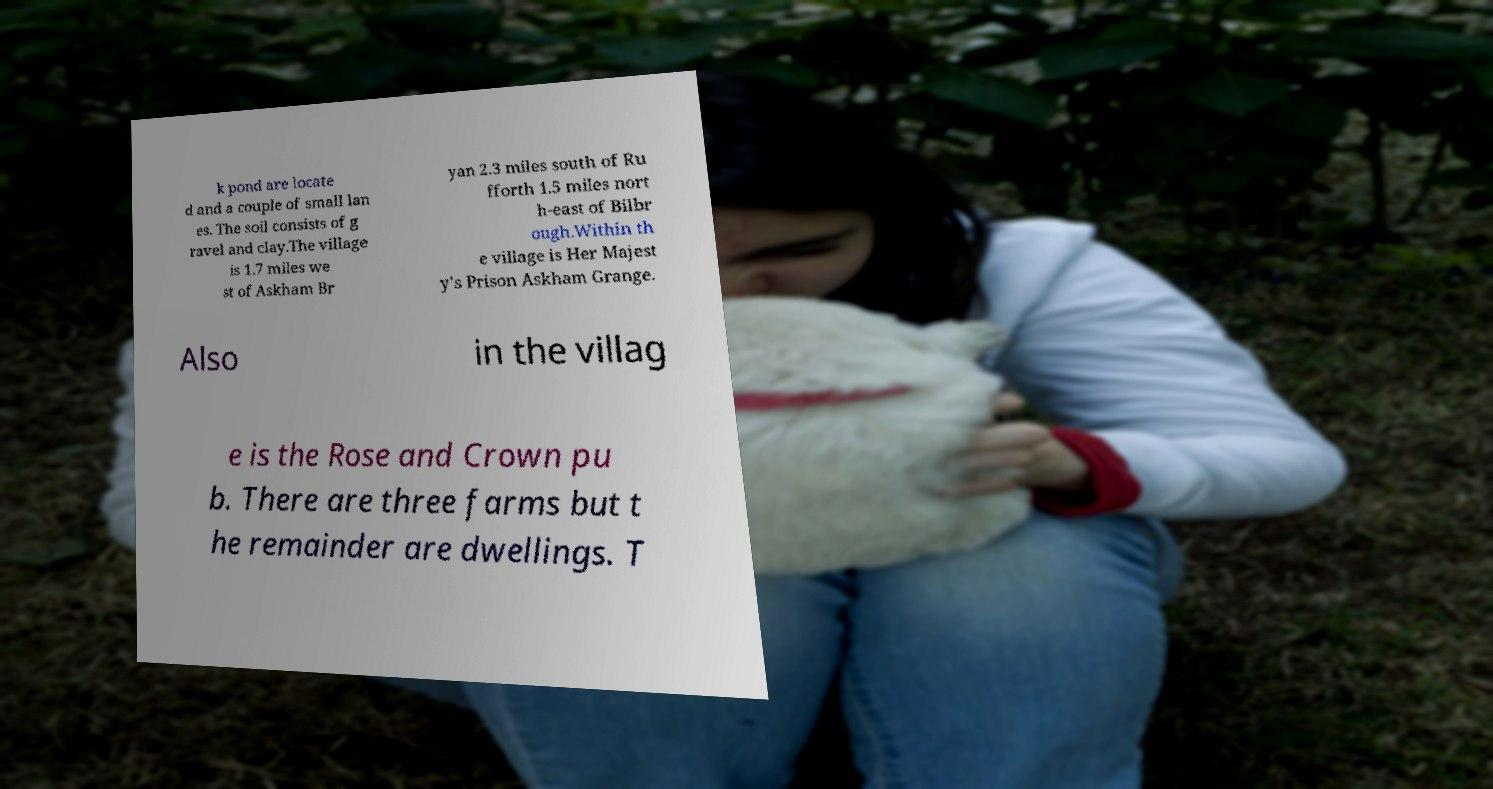For documentation purposes, I need the text within this image transcribed. Could you provide that? k pond are locate d and a couple of small lan es. The soil consists of g ravel and clay.The village is 1.7 miles we st of Askham Br yan 2.3 miles south of Ru fforth 1.5 miles nort h-east of Bilbr ough.Within th e village is Her Majest y's Prison Askham Grange. Also in the villag e is the Rose and Crown pu b. There are three farms but t he remainder are dwellings. T 